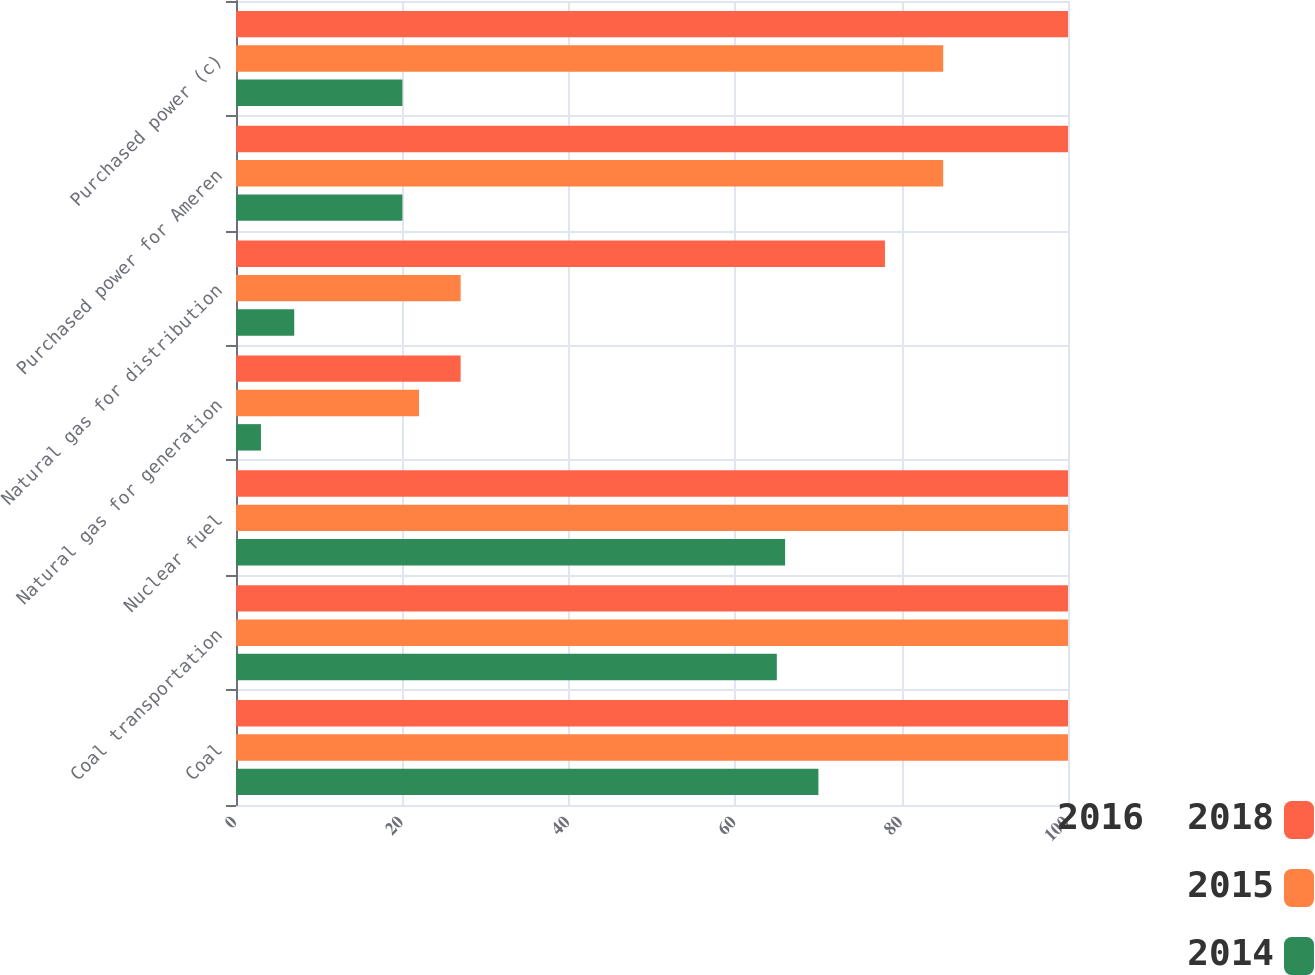<chart> <loc_0><loc_0><loc_500><loc_500><stacked_bar_chart><ecel><fcel>Coal<fcel>Coal transportation<fcel>Nuclear fuel<fcel>Natural gas for generation<fcel>Natural gas for distribution<fcel>Purchased power for Ameren<fcel>Purchased power (c)<nl><fcel>2016  2018<fcel>100<fcel>100<fcel>100<fcel>27<fcel>78<fcel>100<fcel>100<nl><fcel>2015<fcel>100<fcel>100<fcel>100<fcel>22<fcel>27<fcel>85<fcel>85<nl><fcel>2014<fcel>70<fcel>65<fcel>66<fcel>3<fcel>7<fcel>20<fcel>20<nl></chart> 